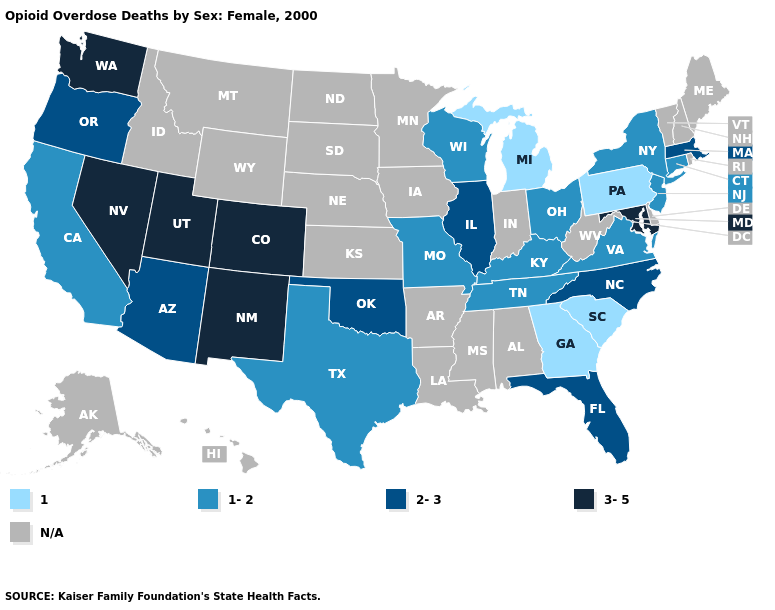What is the highest value in states that border Wyoming?
Short answer required. 3-5. Does the map have missing data?
Be succinct. Yes. What is the value of Rhode Island?
Answer briefly. N/A. Does the first symbol in the legend represent the smallest category?
Short answer required. Yes. Does New Mexico have the highest value in the West?
Be succinct. Yes. Name the states that have a value in the range 3-5?
Give a very brief answer. Colorado, Maryland, Nevada, New Mexico, Utah, Washington. What is the lowest value in the South?
Short answer required. 1. What is the value of Missouri?
Keep it brief. 1-2. Name the states that have a value in the range 3-5?
Answer briefly. Colorado, Maryland, Nevada, New Mexico, Utah, Washington. Among the states that border North Carolina , which have the lowest value?
Concise answer only. Georgia, South Carolina. What is the value of Wyoming?
Concise answer only. N/A. Does the first symbol in the legend represent the smallest category?
Concise answer only. Yes. Which states hav the highest value in the South?
Be succinct. Maryland. Which states hav the highest value in the West?
Be succinct. Colorado, Nevada, New Mexico, Utah, Washington. 